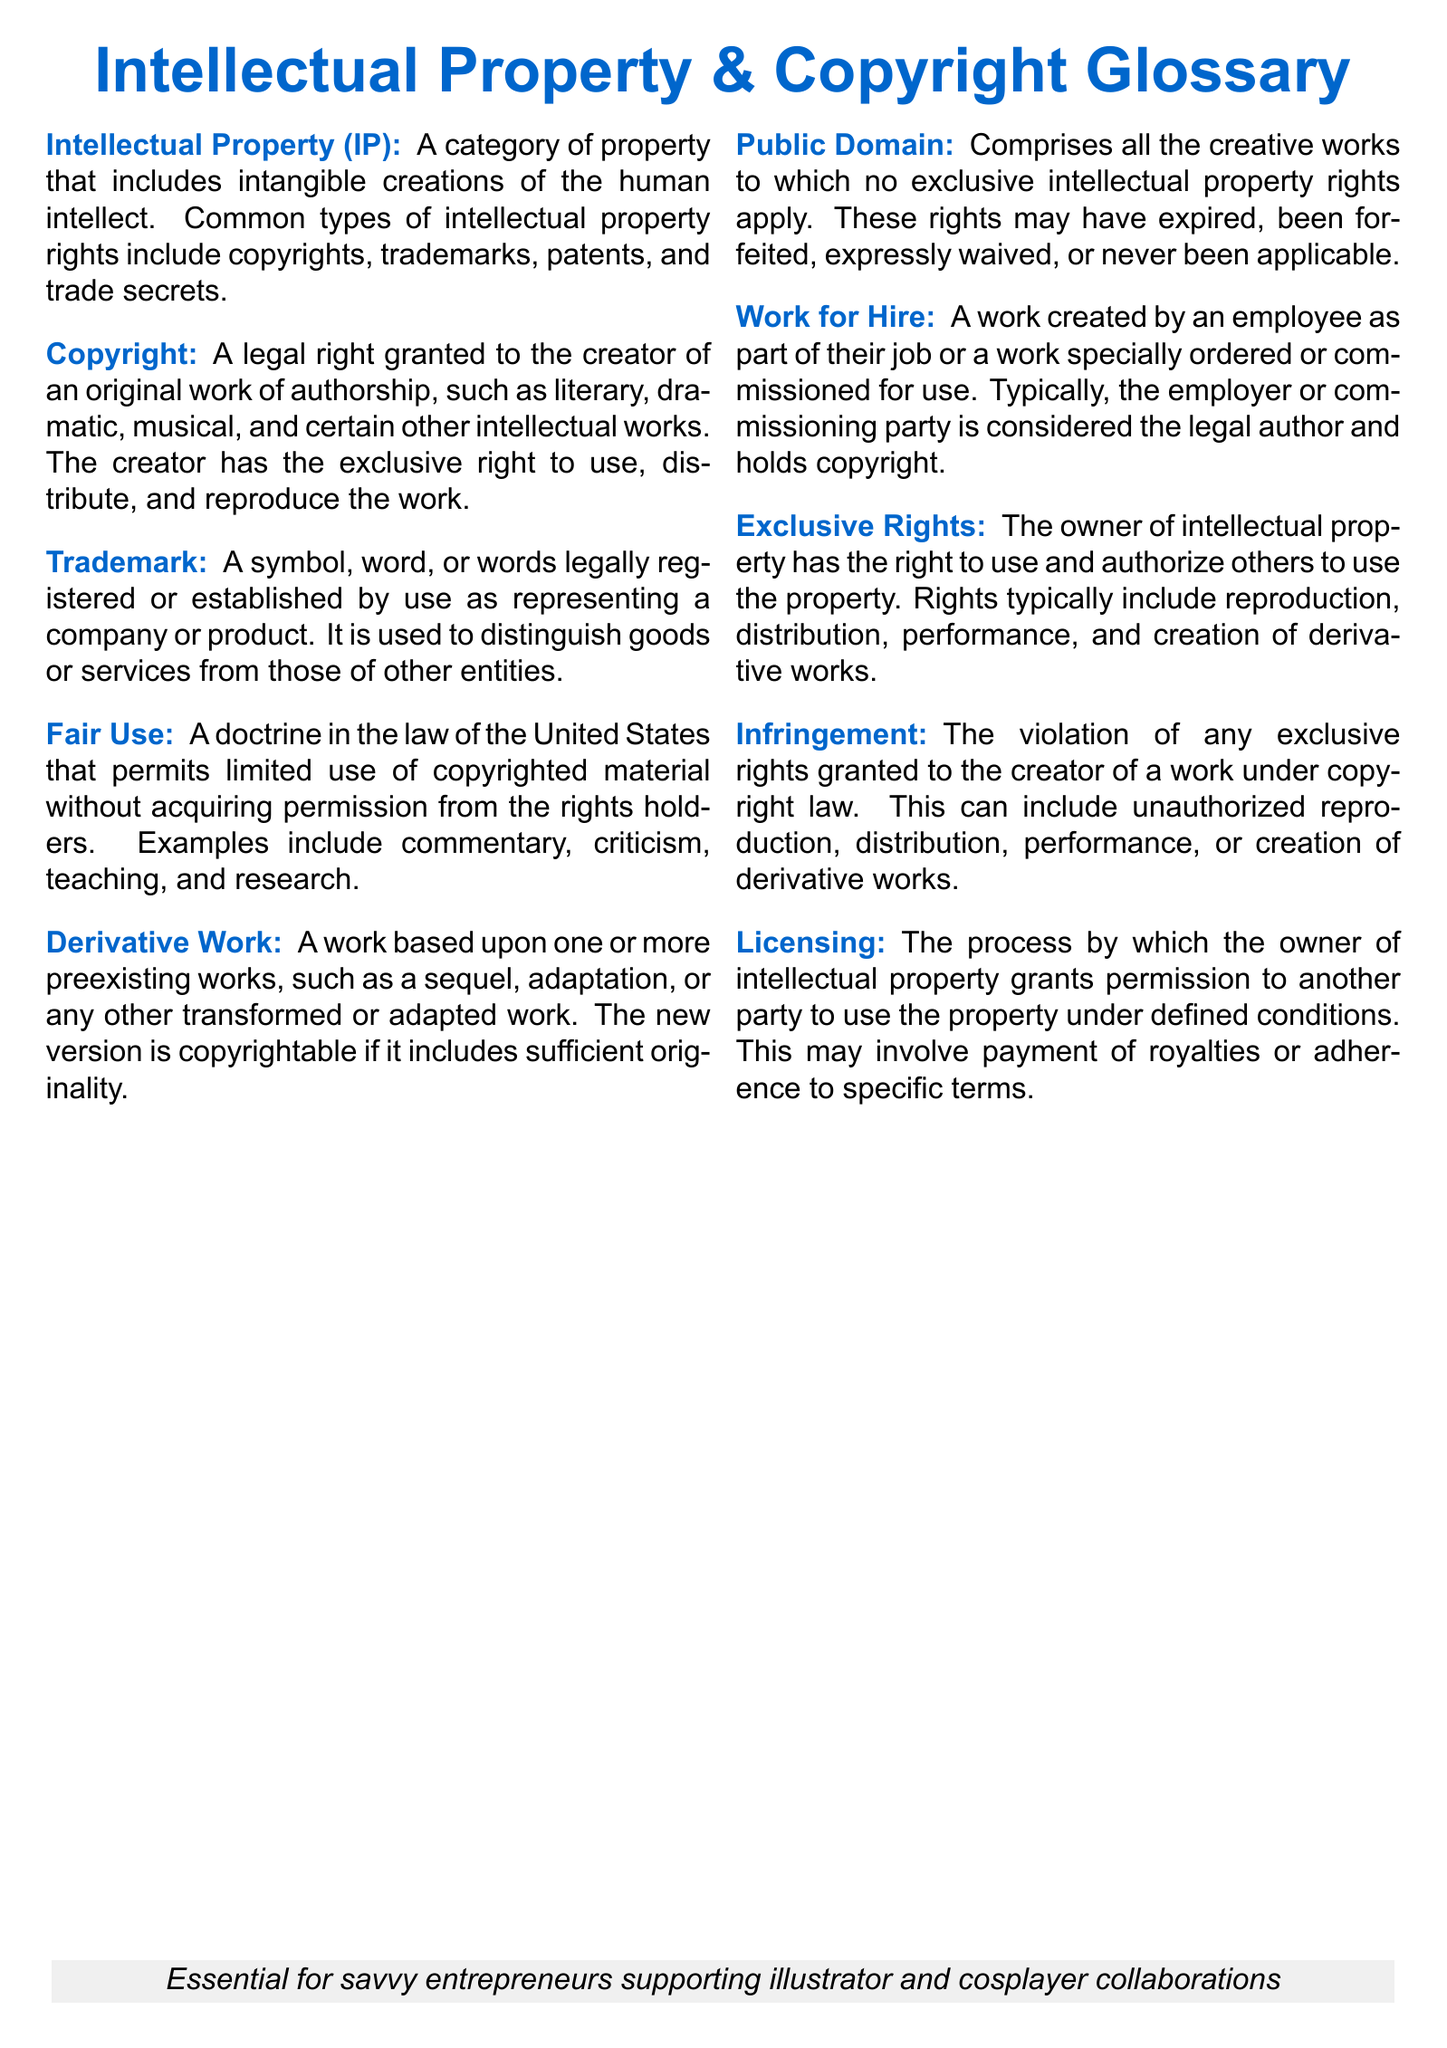What is the definition of Intellectual Property? Intellectual Property is defined as a category of property that includes intangible creations of the human intellect.
Answer: A category of property that includes intangible creations of the human intellect What legal right is granted to the creator of an original work? The legal right granted to the creator of an original work is known as copyright.
Answer: Copyright What type of work is a sequel or adaptation considered? A sequel or adaptation is considered a derivative work.
Answer: Derivative Work What is required for a work created by an employee as part of their job? A work created by an employee as part of their job is classified as a work for hire.
Answer: Work for Hire Which doctrine permits limited use of copyrighted material? The doctrine that permits limited use of copyrighted material is called fair use.
Answer: Fair Use What is the legal term for unauthorized reproduction or distribution of work? The legal term for this violation is infringement.
Answer: Infringement What is the purpose of licensing in intellectual property? The purpose of licensing is to grant permission to another party to use the property under defined conditions.
Answer: Grant permission What are the rights typically included in exclusive rights? Exclusive rights typically include reproduction, distribution, performance, and creation of derivative works.
Answer: Reproduction, distribution, performance, creation of derivative works What is the public domain? The public domain comprises all the creative works to which no exclusive intellectual property rights apply.
Answer: All creative works to which no exclusive intellectual property rights apply 